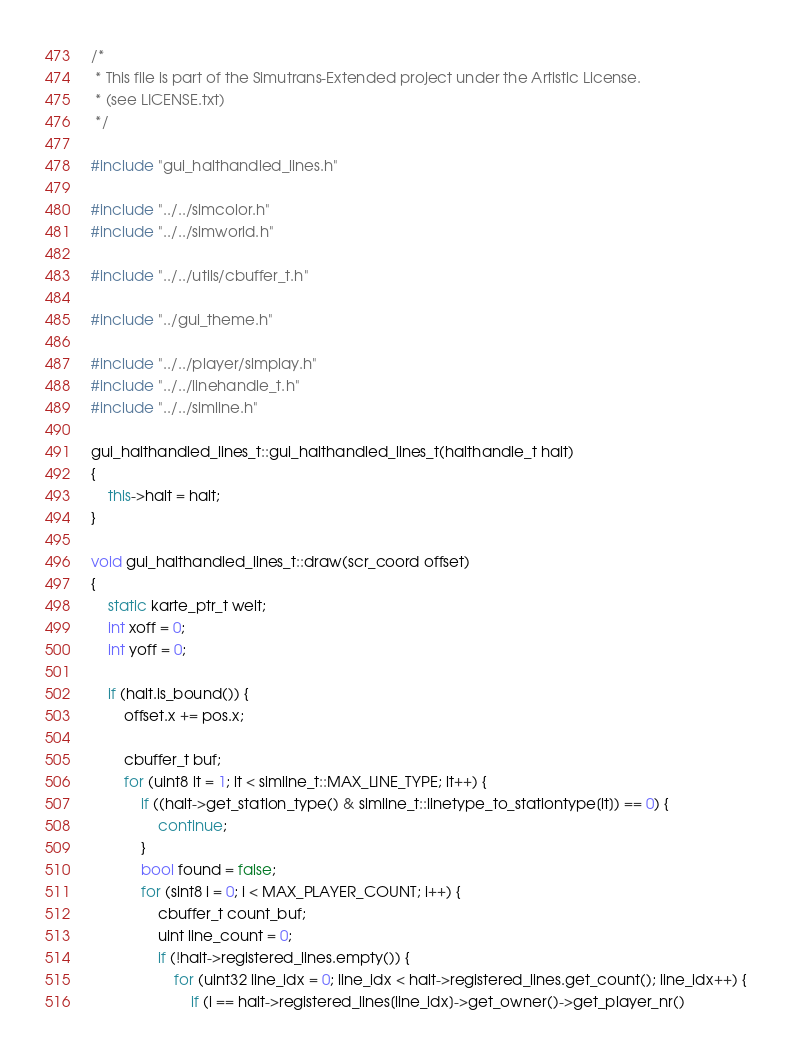Convert code to text. <code><loc_0><loc_0><loc_500><loc_500><_C++_>/*
 * This file is part of the Simutrans-Extended project under the Artistic License.
 * (see LICENSE.txt)
 */

#include "gui_halthandled_lines.h"

#include "../../simcolor.h"
#include "../../simworld.h"

#include "../../utils/cbuffer_t.h"

#include "../gui_theme.h"

#include "../../player/simplay.h"
#include "../../linehandle_t.h"
#include "../../simline.h"

gui_halthandled_lines_t::gui_halthandled_lines_t(halthandle_t halt)
{
	this->halt = halt;
}

void gui_halthandled_lines_t::draw(scr_coord offset)
{
	static karte_ptr_t welt;
	int xoff = 0;
	int yoff = 0;

	if (halt.is_bound()) {
		offset.x += pos.x;

		cbuffer_t buf;
		for (uint8 lt = 1; lt < simline_t::MAX_LINE_TYPE; lt++) {
			if ((halt->get_station_type() & simline_t::linetype_to_stationtype[lt]) == 0) {
				continue;
			}
			bool found = false;
			for (sint8 i = 0; i < MAX_PLAYER_COUNT; i++) {
				cbuffer_t count_buf;
				uint line_count = 0;
				if (!halt->registered_lines.empty()) {
					for (uint32 line_idx = 0; line_idx < halt->registered_lines.get_count(); line_idx++) {
						if (i == halt->registered_lines[line_idx]->get_owner()->get_player_nr()</code> 